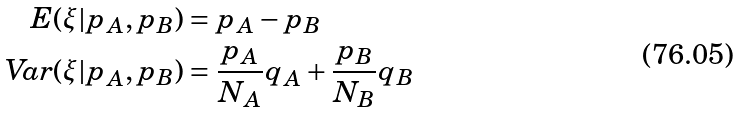Convert formula to latex. <formula><loc_0><loc_0><loc_500><loc_500>E ( \xi | p _ { A } , p _ { B } ) & = p _ { A } - p _ { B } \\ \text {Var} ( \xi | p _ { A } , p _ { B } ) & = \frac { p _ { A } } { N _ { A } } q _ { A } + \frac { p _ { B } } { N _ { B } } q _ { B }</formula> 